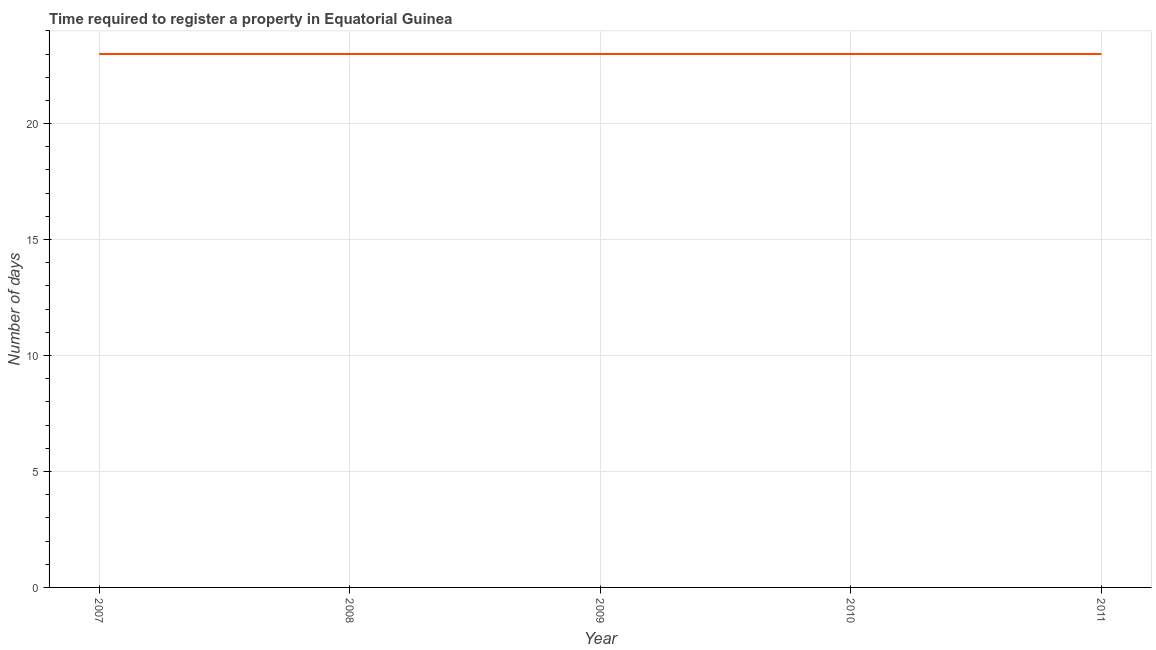What is the number of days required to register property in 2010?
Provide a short and direct response. 23. Across all years, what is the maximum number of days required to register property?
Provide a succinct answer. 23. Across all years, what is the minimum number of days required to register property?
Give a very brief answer. 23. In which year was the number of days required to register property minimum?
Your response must be concise. 2007. What is the sum of the number of days required to register property?
Offer a very short reply. 115. What is the difference between the number of days required to register property in 2008 and 2009?
Your answer should be compact. 0. In how many years, is the number of days required to register property greater than 19 days?
Give a very brief answer. 5. Do a majority of the years between 2010 and 2011 (inclusive) have number of days required to register property greater than 12 days?
Offer a very short reply. Yes. What is the difference between the highest and the second highest number of days required to register property?
Offer a terse response. 0. In how many years, is the number of days required to register property greater than the average number of days required to register property taken over all years?
Your answer should be very brief. 0. Does the number of days required to register property monotonically increase over the years?
Provide a short and direct response. No. How many lines are there?
Your answer should be compact. 1. What is the difference between two consecutive major ticks on the Y-axis?
Ensure brevity in your answer.  5. Does the graph contain any zero values?
Provide a short and direct response. No. What is the title of the graph?
Offer a terse response. Time required to register a property in Equatorial Guinea. What is the label or title of the Y-axis?
Ensure brevity in your answer.  Number of days. What is the Number of days in 2008?
Your response must be concise. 23. What is the Number of days of 2010?
Offer a terse response. 23. What is the Number of days in 2011?
Make the answer very short. 23. What is the difference between the Number of days in 2007 and 2008?
Ensure brevity in your answer.  0. What is the difference between the Number of days in 2007 and 2010?
Your response must be concise. 0. What is the difference between the Number of days in 2009 and 2010?
Provide a succinct answer. 0. What is the difference between the Number of days in 2010 and 2011?
Keep it short and to the point. 0. What is the ratio of the Number of days in 2007 to that in 2008?
Your response must be concise. 1. What is the ratio of the Number of days in 2007 to that in 2010?
Make the answer very short. 1. What is the ratio of the Number of days in 2007 to that in 2011?
Your answer should be compact. 1. What is the ratio of the Number of days in 2008 to that in 2009?
Keep it short and to the point. 1. What is the ratio of the Number of days in 2008 to that in 2011?
Your answer should be compact. 1. What is the ratio of the Number of days in 2009 to that in 2010?
Ensure brevity in your answer.  1. What is the ratio of the Number of days in 2010 to that in 2011?
Make the answer very short. 1. 